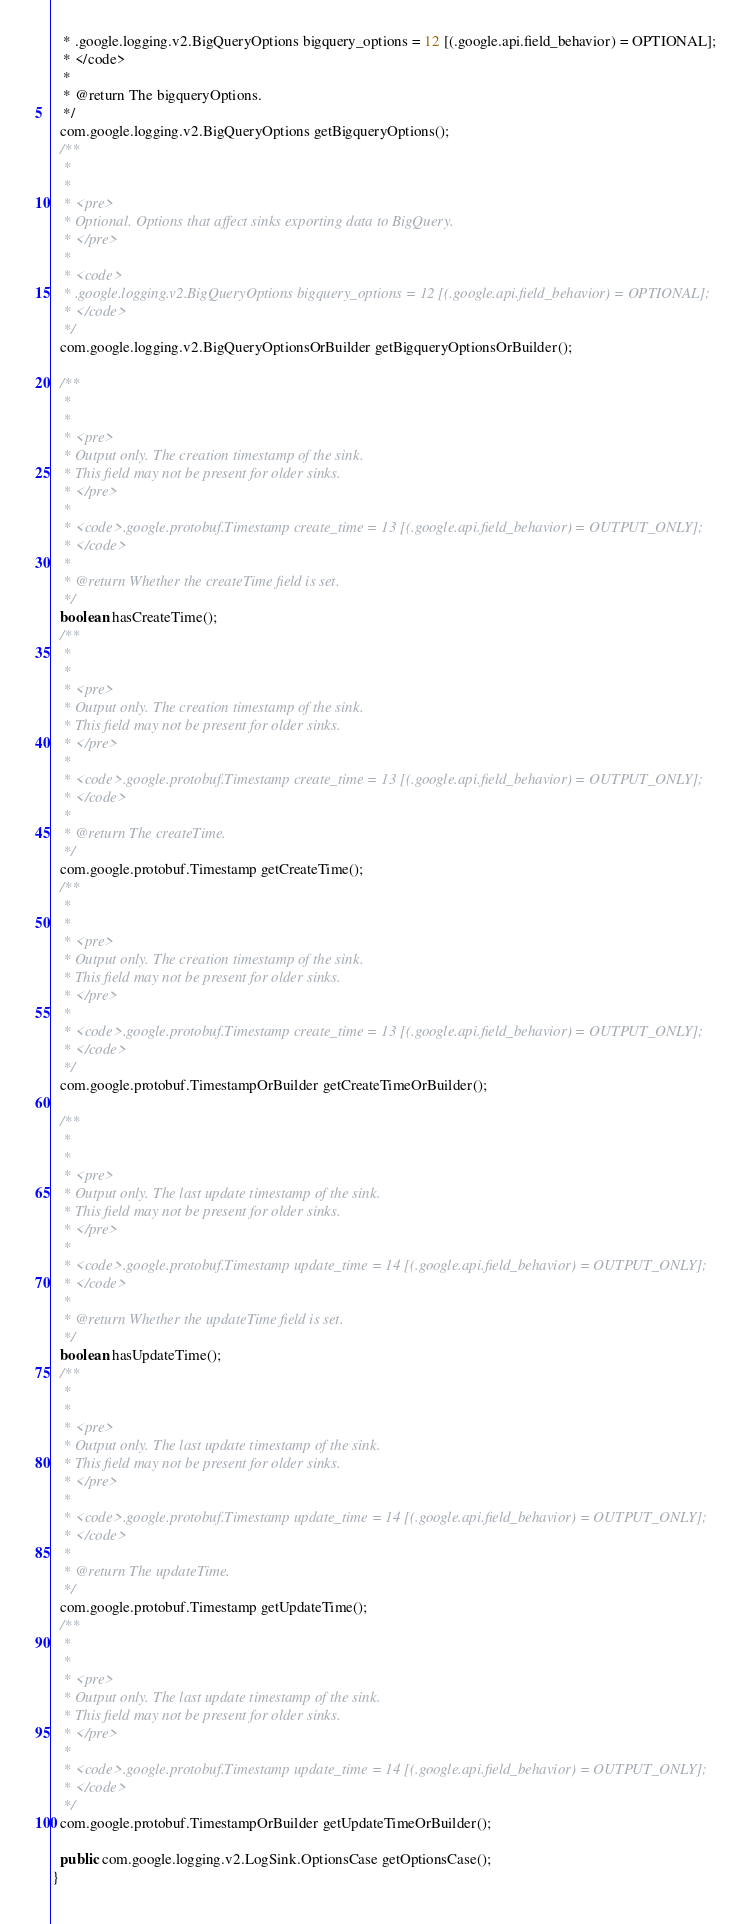Convert code to text. <code><loc_0><loc_0><loc_500><loc_500><_Java_>   * .google.logging.v2.BigQueryOptions bigquery_options = 12 [(.google.api.field_behavior) = OPTIONAL];
   * </code>
   *
   * @return The bigqueryOptions.
   */
  com.google.logging.v2.BigQueryOptions getBigqueryOptions();
  /**
   *
   *
   * <pre>
   * Optional. Options that affect sinks exporting data to BigQuery.
   * </pre>
   *
   * <code>
   * .google.logging.v2.BigQueryOptions bigquery_options = 12 [(.google.api.field_behavior) = OPTIONAL];
   * </code>
   */
  com.google.logging.v2.BigQueryOptionsOrBuilder getBigqueryOptionsOrBuilder();

  /**
   *
   *
   * <pre>
   * Output only. The creation timestamp of the sink.
   * This field may not be present for older sinks.
   * </pre>
   *
   * <code>.google.protobuf.Timestamp create_time = 13 [(.google.api.field_behavior) = OUTPUT_ONLY];
   * </code>
   *
   * @return Whether the createTime field is set.
   */
  boolean hasCreateTime();
  /**
   *
   *
   * <pre>
   * Output only. The creation timestamp of the sink.
   * This field may not be present for older sinks.
   * </pre>
   *
   * <code>.google.protobuf.Timestamp create_time = 13 [(.google.api.field_behavior) = OUTPUT_ONLY];
   * </code>
   *
   * @return The createTime.
   */
  com.google.protobuf.Timestamp getCreateTime();
  /**
   *
   *
   * <pre>
   * Output only. The creation timestamp of the sink.
   * This field may not be present for older sinks.
   * </pre>
   *
   * <code>.google.protobuf.Timestamp create_time = 13 [(.google.api.field_behavior) = OUTPUT_ONLY];
   * </code>
   */
  com.google.protobuf.TimestampOrBuilder getCreateTimeOrBuilder();

  /**
   *
   *
   * <pre>
   * Output only. The last update timestamp of the sink.
   * This field may not be present for older sinks.
   * </pre>
   *
   * <code>.google.protobuf.Timestamp update_time = 14 [(.google.api.field_behavior) = OUTPUT_ONLY];
   * </code>
   *
   * @return Whether the updateTime field is set.
   */
  boolean hasUpdateTime();
  /**
   *
   *
   * <pre>
   * Output only. The last update timestamp of the sink.
   * This field may not be present for older sinks.
   * </pre>
   *
   * <code>.google.protobuf.Timestamp update_time = 14 [(.google.api.field_behavior) = OUTPUT_ONLY];
   * </code>
   *
   * @return The updateTime.
   */
  com.google.protobuf.Timestamp getUpdateTime();
  /**
   *
   *
   * <pre>
   * Output only. The last update timestamp of the sink.
   * This field may not be present for older sinks.
   * </pre>
   *
   * <code>.google.protobuf.Timestamp update_time = 14 [(.google.api.field_behavior) = OUTPUT_ONLY];
   * </code>
   */
  com.google.protobuf.TimestampOrBuilder getUpdateTimeOrBuilder();

  public com.google.logging.v2.LogSink.OptionsCase getOptionsCase();
}
</code> 